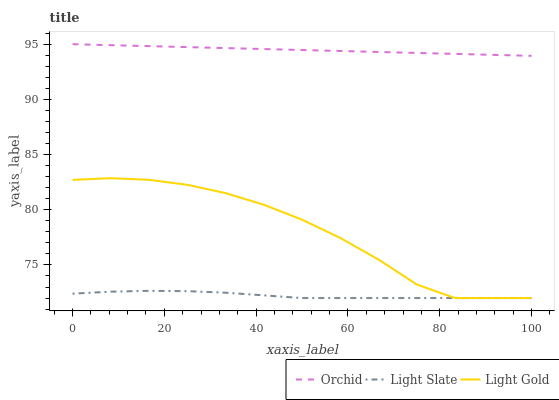Does Light Slate have the minimum area under the curve?
Answer yes or no. Yes. Does Orchid have the maximum area under the curve?
Answer yes or no. Yes. Does Light Gold have the minimum area under the curve?
Answer yes or no. No. Does Light Gold have the maximum area under the curve?
Answer yes or no. No. Is Orchid the smoothest?
Answer yes or no. Yes. Is Light Gold the roughest?
Answer yes or no. Yes. Is Light Gold the smoothest?
Answer yes or no. No. Is Orchid the roughest?
Answer yes or no. No. Does Light Slate have the lowest value?
Answer yes or no. Yes. Does Orchid have the lowest value?
Answer yes or no. No. Does Orchid have the highest value?
Answer yes or no. Yes. Does Light Gold have the highest value?
Answer yes or no. No. Is Light Gold less than Orchid?
Answer yes or no. Yes. Is Orchid greater than Light Slate?
Answer yes or no. Yes. Does Light Slate intersect Light Gold?
Answer yes or no. Yes. Is Light Slate less than Light Gold?
Answer yes or no. No. Is Light Slate greater than Light Gold?
Answer yes or no. No. Does Light Gold intersect Orchid?
Answer yes or no. No. 